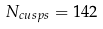Convert formula to latex. <formula><loc_0><loc_0><loc_500><loc_500>N _ { c u s p s } = 1 4 2</formula> 